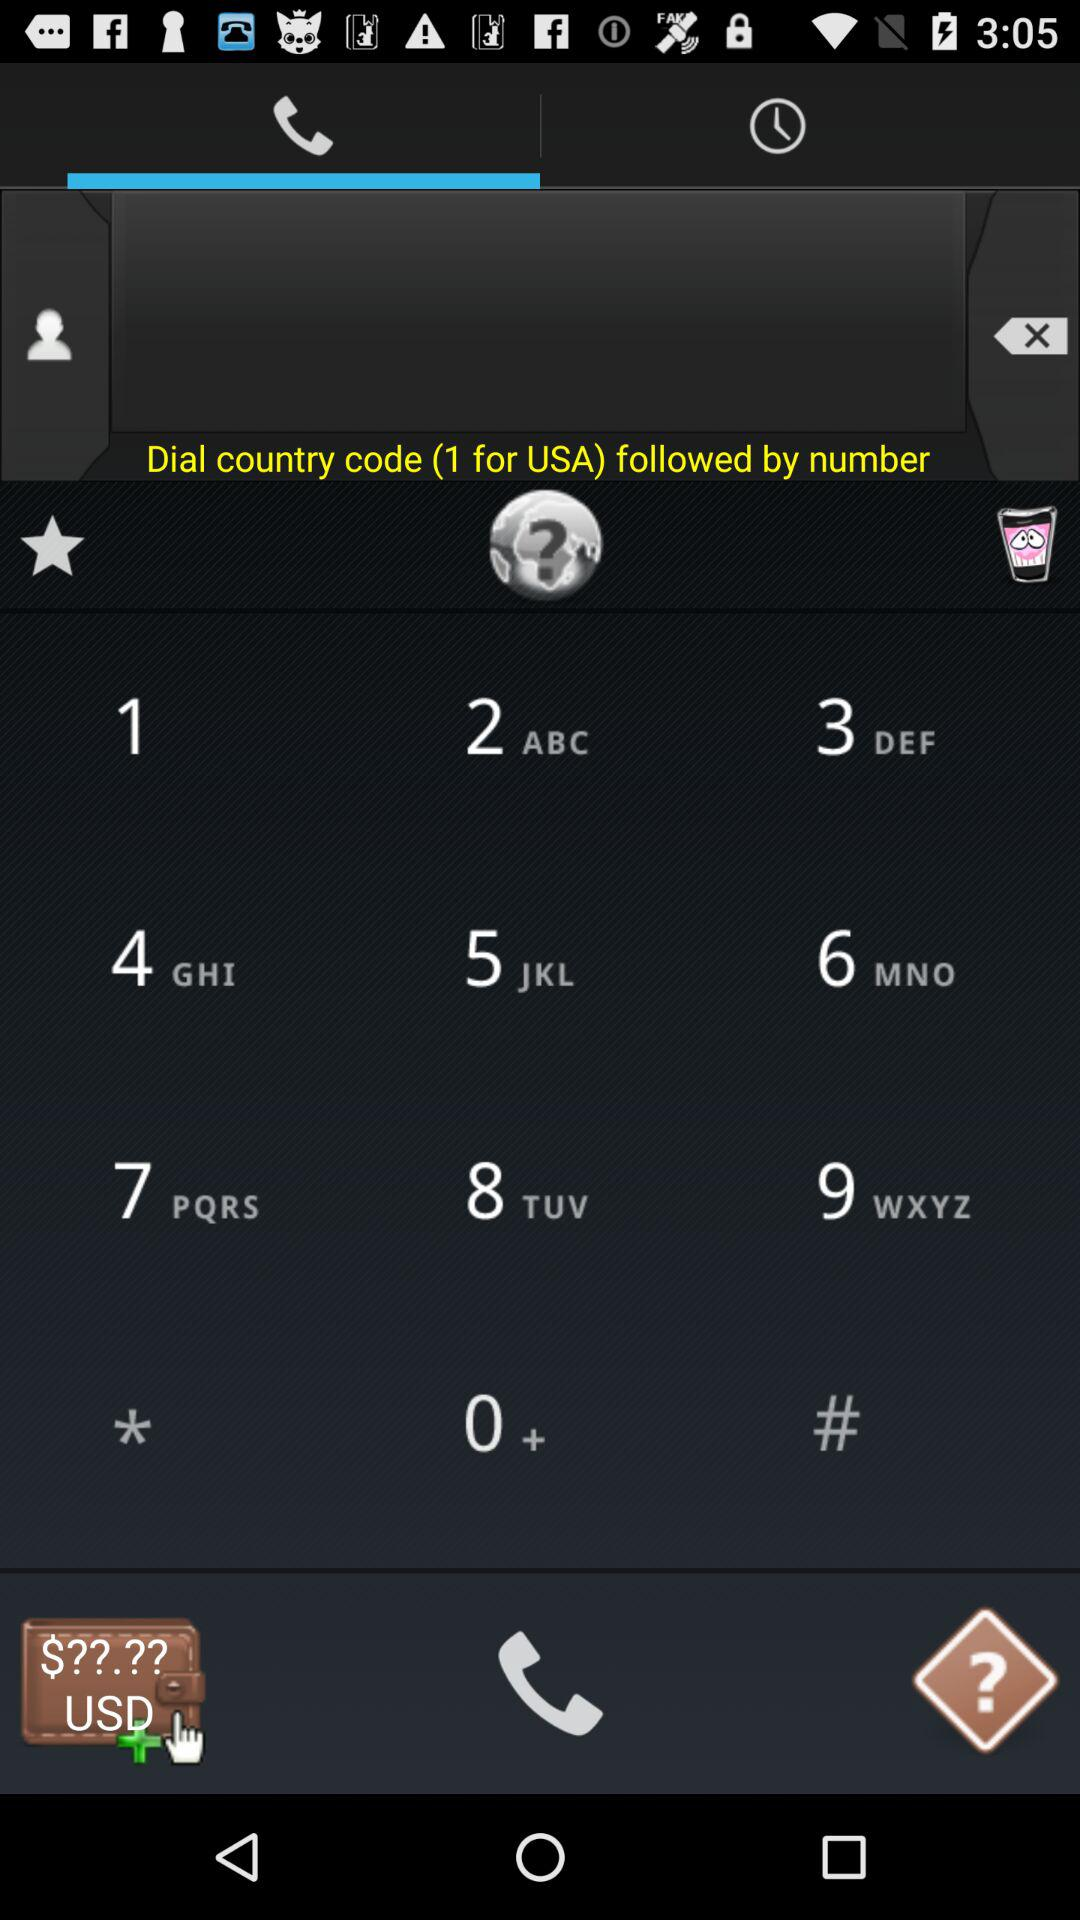Which tab am I on? You are on "Phone" tab. 